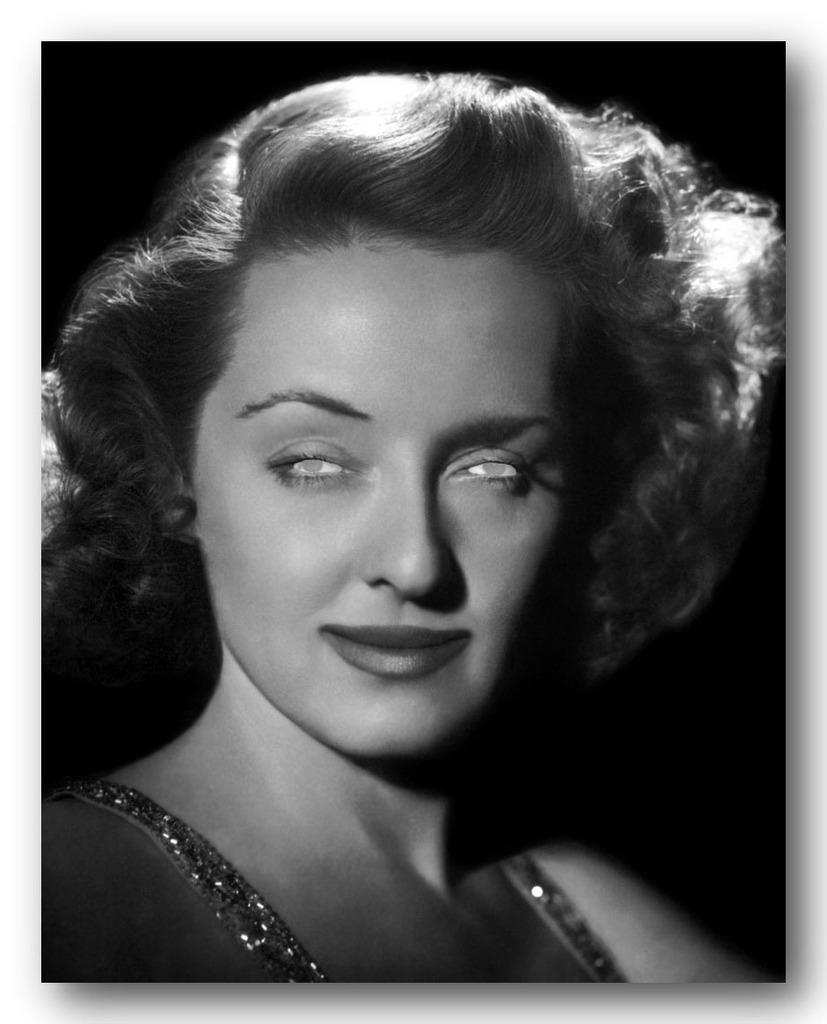Who is the main subject in the image? There is a girl in the image. What can be observed about the background of the image? The background of the image is dark. Can you see any ducks or goldfish in the image? There are no ducks or goldfish present in the image. What type of harmony is being played in the background of the image? There is no music or harmony present in the image; it only features a girl and a dark background. 